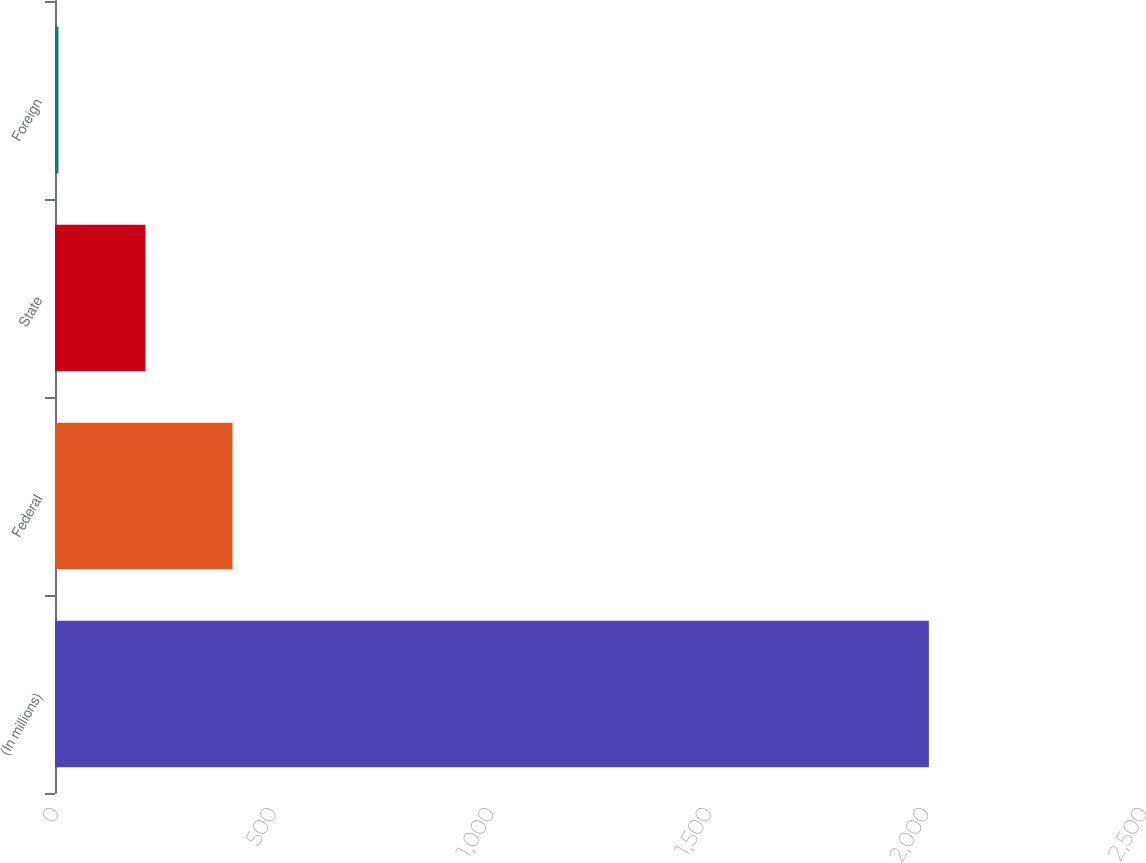Convert chart to OTSL. <chart><loc_0><loc_0><loc_500><loc_500><bar_chart><fcel>(In millions)<fcel>Federal<fcel>State<fcel>Foreign<nl><fcel>2008<fcel>408<fcel>208<fcel>8<nl></chart> 